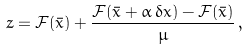Convert formula to latex. <formula><loc_0><loc_0><loc_500><loc_500>z = \mathcal { F } ( \bar { x } ) + \frac { \mathcal { F } ( \bar { x } + \alpha \, \delta x ) - \mathcal { F } ( \bar { x } ) } { \mu } \, ,</formula> 